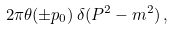<formula> <loc_0><loc_0><loc_500><loc_500>2 \pi \theta ( \pm p _ { 0 } ) \, \delta ( P ^ { 2 } - m ^ { 2 } ) \, ,</formula> 